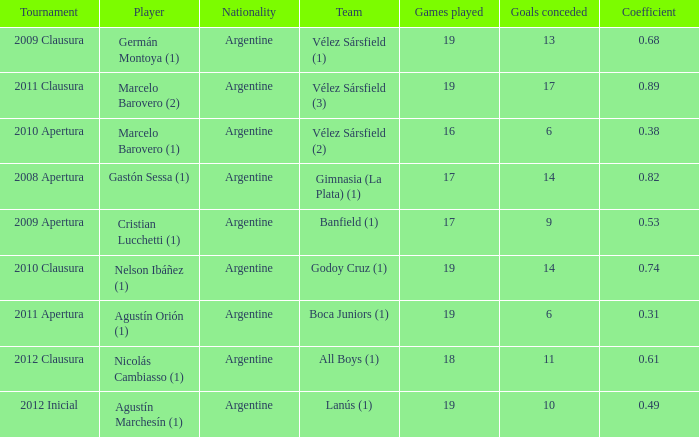 the 2010 clausura tournament? 0.74. Would you be able to parse every entry in this table? {'header': ['Tournament', 'Player', 'Nationality', 'Team', 'Games played', 'Goals conceded', 'Coefficient'], 'rows': [['2009 Clausura', 'Germán Montoya (1)', 'Argentine', 'Vélez Sársfield (1)', '19', '13', '0.68'], ['2011 Clausura', 'Marcelo Barovero (2)', 'Argentine', 'Vélez Sársfield (3)', '19', '17', '0.89'], ['2010 Apertura', 'Marcelo Barovero (1)', 'Argentine', 'Vélez Sársfield (2)', '16', '6', '0.38'], ['2008 Apertura', 'Gastón Sessa (1)', 'Argentine', 'Gimnasia (La Plata) (1)', '17', '14', '0.82'], ['2009 Apertura', 'Cristian Lucchetti (1)', 'Argentine', 'Banfield (1)', '17', '9', '0.53'], ['2010 Clausura', 'Nelson Ibáñez (1)', 'Argentine', 'Godoy Cruz (1)', '19', '14', '0.74'], ['2011 Apertura', 'Agustín Orión (1)', 'Argentine', 'Boca Juniors (1)', '19', '6', '0.31'], ['2012 Clausura', 'Nicolás Cambiasso (1)', 'Argentine', 'All Boys (1)', '18', '11', '0.61'], ['2012 Inicial', 'Agustín Marchesín (1)', 'Argentine', 'Lanús (1)', '19', '10', '0.49']]} 